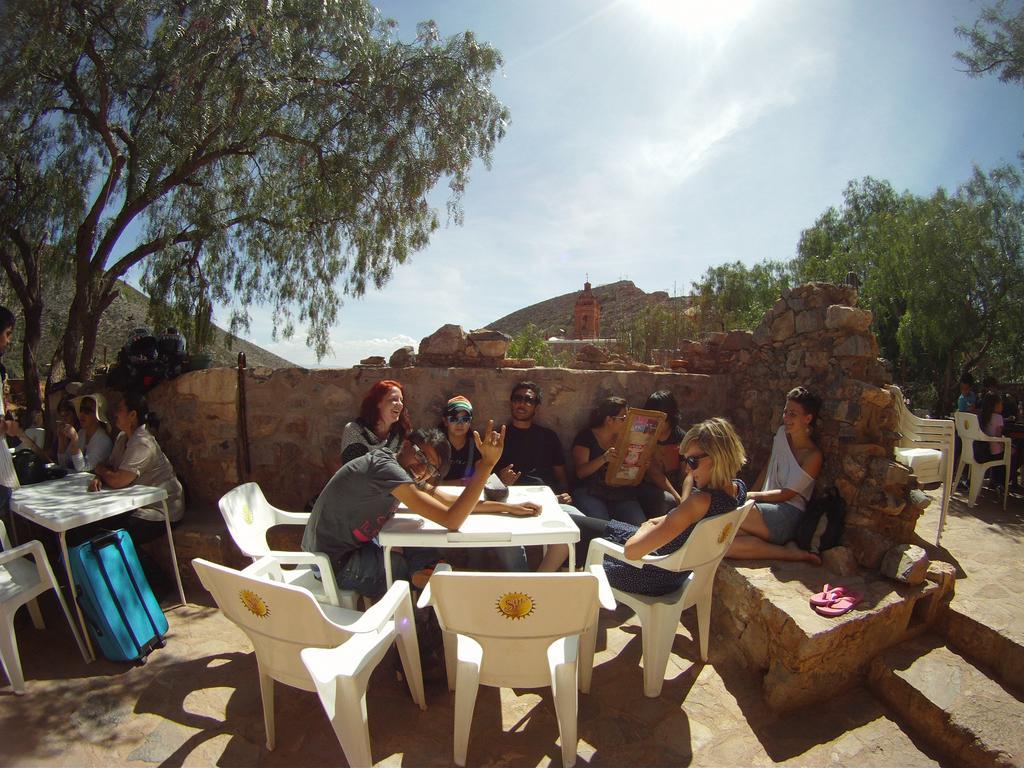How would you summarize this image in a sentence or two? In the center we can see group of persons were sitting on the chair around the table. In front we can see few empty chairs. On the left again few persons were sitting around the table. In the background there is a sky with clouds,sun,trees,hill,slipper and chairs. 